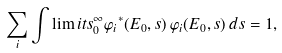<formula> <loc_0><loc_0><loc_500><loc_500>\sum _ { i } \int \lim i t s _ { 0 } ^ { \infty } { \varphi _ { i } } ^ { * } ( E _ { 0 } , s ) \, \varphi _ { i } ( E _ { 0 } , s ) \, d s = 1 ,</formula> 